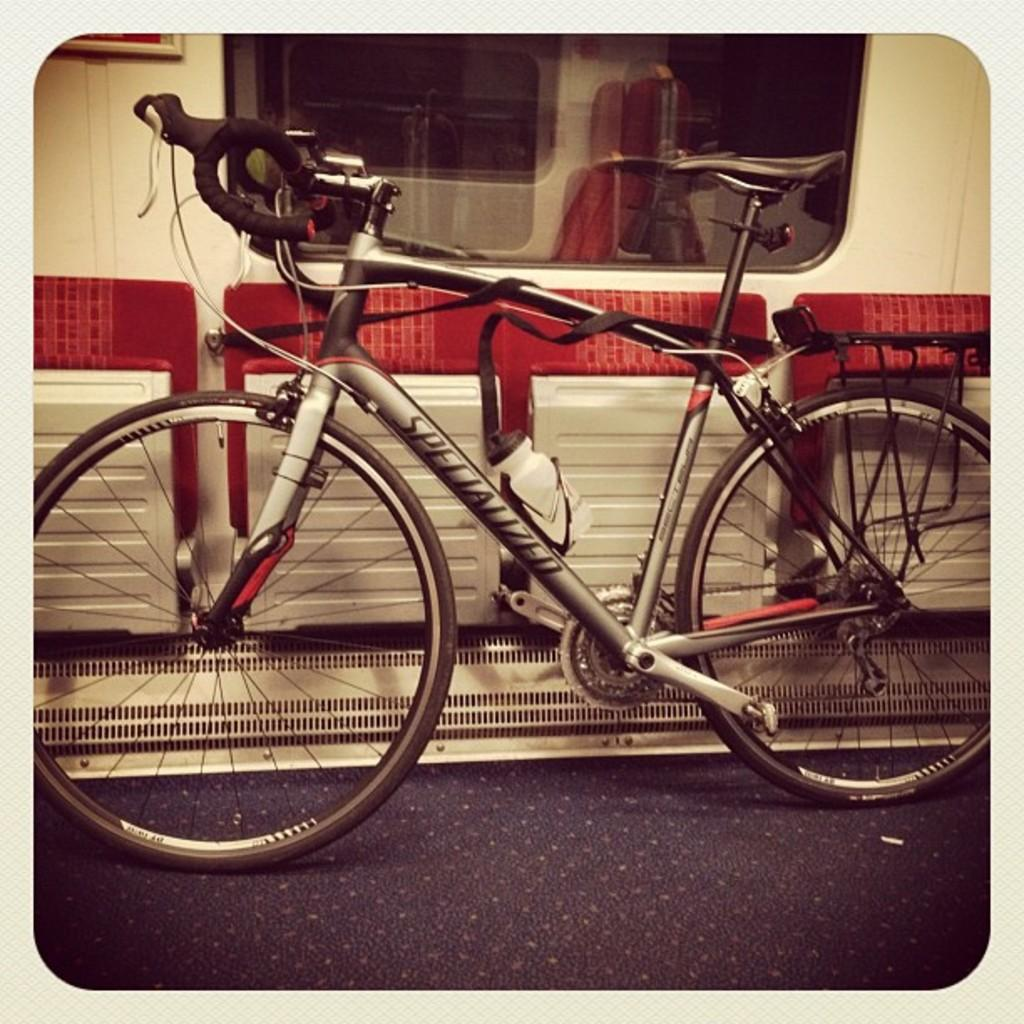What is the main object in the picture? There is a bicycle in the picture. What are the main components of the bicycle? The bicycle has a frame, paddles, wheels, a saddle, and handlebars. What is visible in the background of the picture? There is a glass window in the backdrop of the picture. Can you see any kisses being exchanged between the bicycle and the glass window in the image? No, there are no kisses or any living beings present in the image to exchange kisses. 